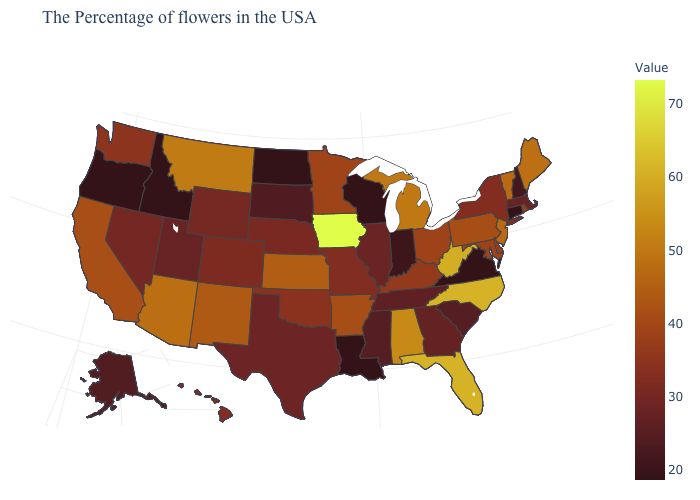Among the states that border Arizona , which have the highest value?
Quick response, please. New Mexico. Which states have the lowest value in the USA?
Give a very brief answer. Connecticut, Virginia, Wisconsin, Louisiana, North Dakota, Idaho, Oregon. Among the states that border Oregon , does California have the lowest value?
Be succinct. No. Does Colorado have the lowest value in the USA?
Answer briefly. No. 